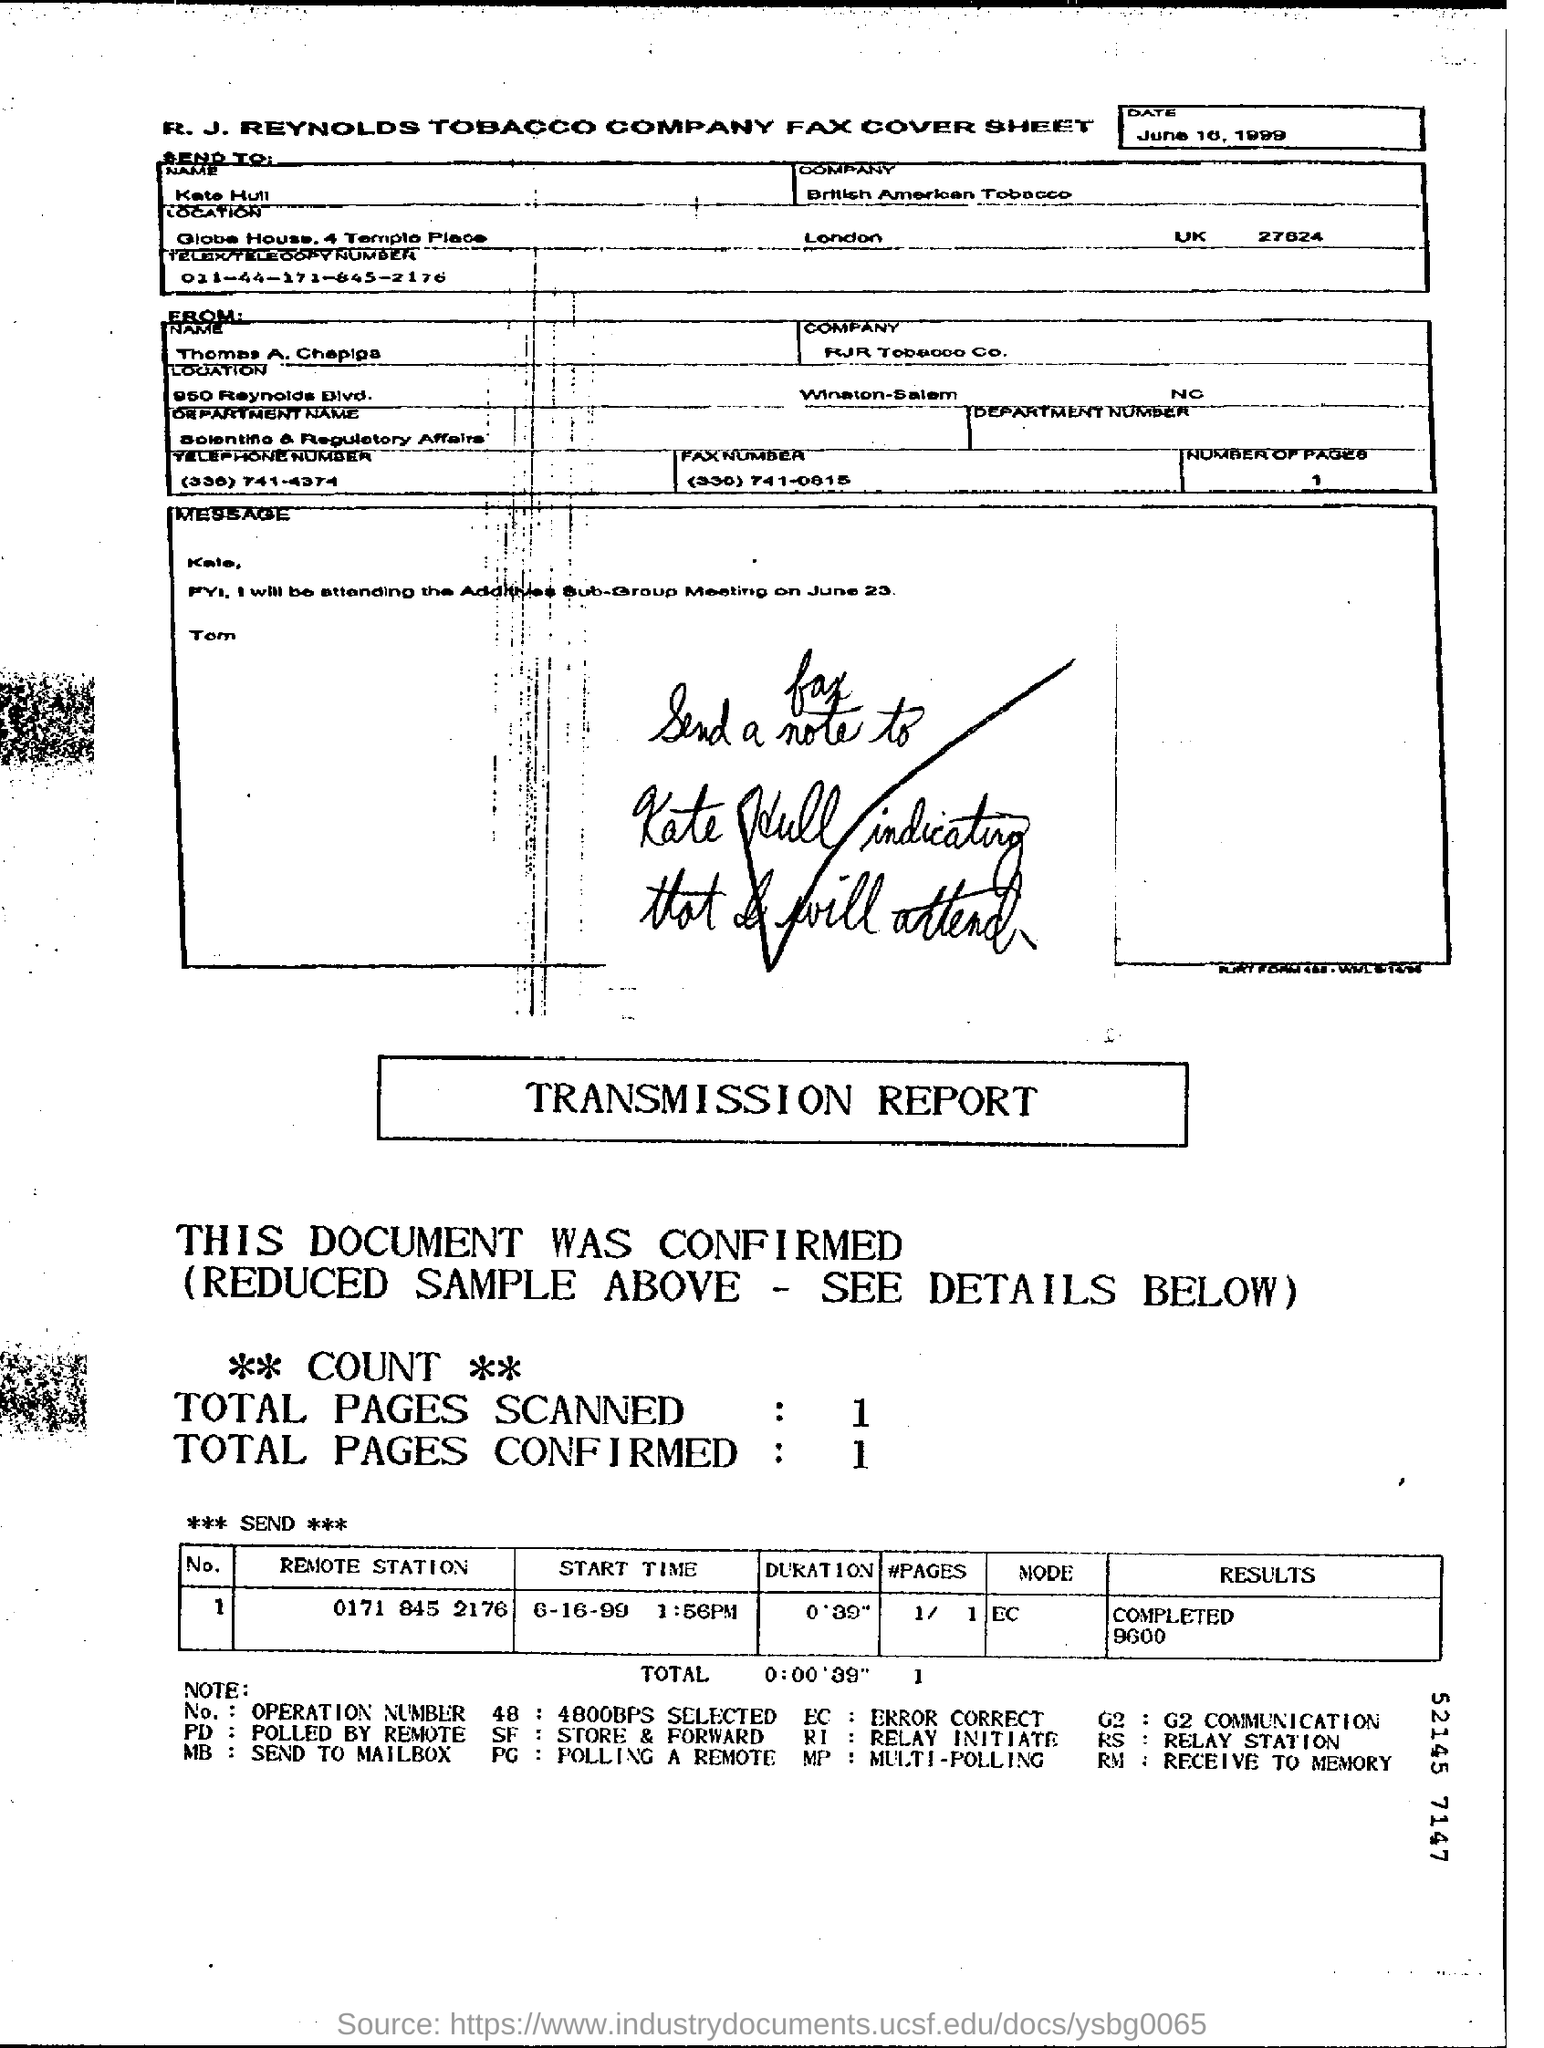Which company's fax cover sheet is this?
Give a very brief answer. R. J. Reynolds Tabacco Company. In which department , Thomas A. Chepiga works?
Keep it short and to the point. Scientific & Regulatory Affairs. In which company, Kate Hull works ?
Your answer should be very brief. British American Tobacco. What is the Start time mentioned in the transmission report?
Ensure brevity in your answer.  6-16-99. 1:56pm. What is the Total duration mentioned in the transmission report?
Provide a succinct answer. 0'39". Which Remote station belongs to Operation Number(No.) 1?
Give a very brief answer. 0171 845 2176. 